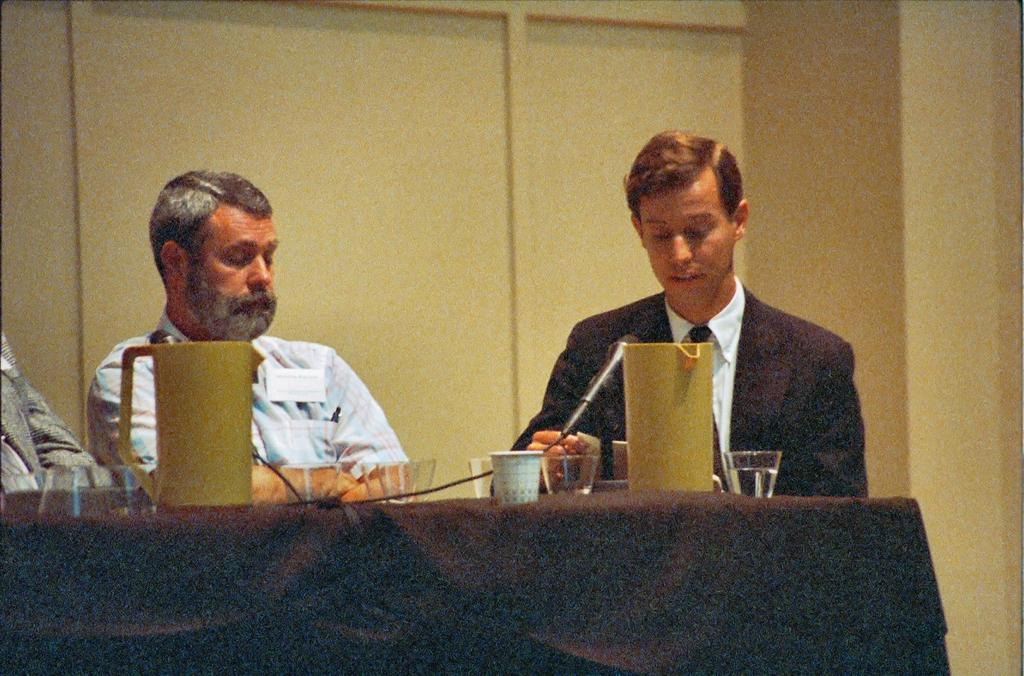How many people are sitting on the chair in the image? There are two men sitting on a chair in the image. What is in front of the men? There is a microphone in front of the men. What can be seen on the table in the image? There is a jug and glasses on the table in the image. What is visible in the background of the image? There is a wall in the background of the image. What type of egg is being cooked on the land in the image? There is no egg or land present in the image. 